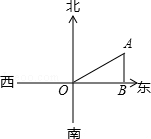If we wanted to calculate the height from the water tower directly down to the highway, how would we determine that using the image? Using the image and the given angle of 60 degrees at point O between the water tower and the horizontal highway, we can calculate the height from point A to the highway (let's call it h). Since in a right-angled triangle, the height corresponds to the side opposite the angle, we can use the sine function again. The sine of 60 degrees is equal to the opposite side (h) divided by the hypotenuse (OA). Given that sin(60) = √3/2 and OA = 2000.0 meters, we can set up the equation sin(60) = h/OA, which allows us to solve for the height as h = OA * sin(60) = 2000.0 * √3/2 = 1000√3 meters. This height is also the same as the distance AB calculated previously and represents how far the water tower is from the highway, measured perpendicularly. 